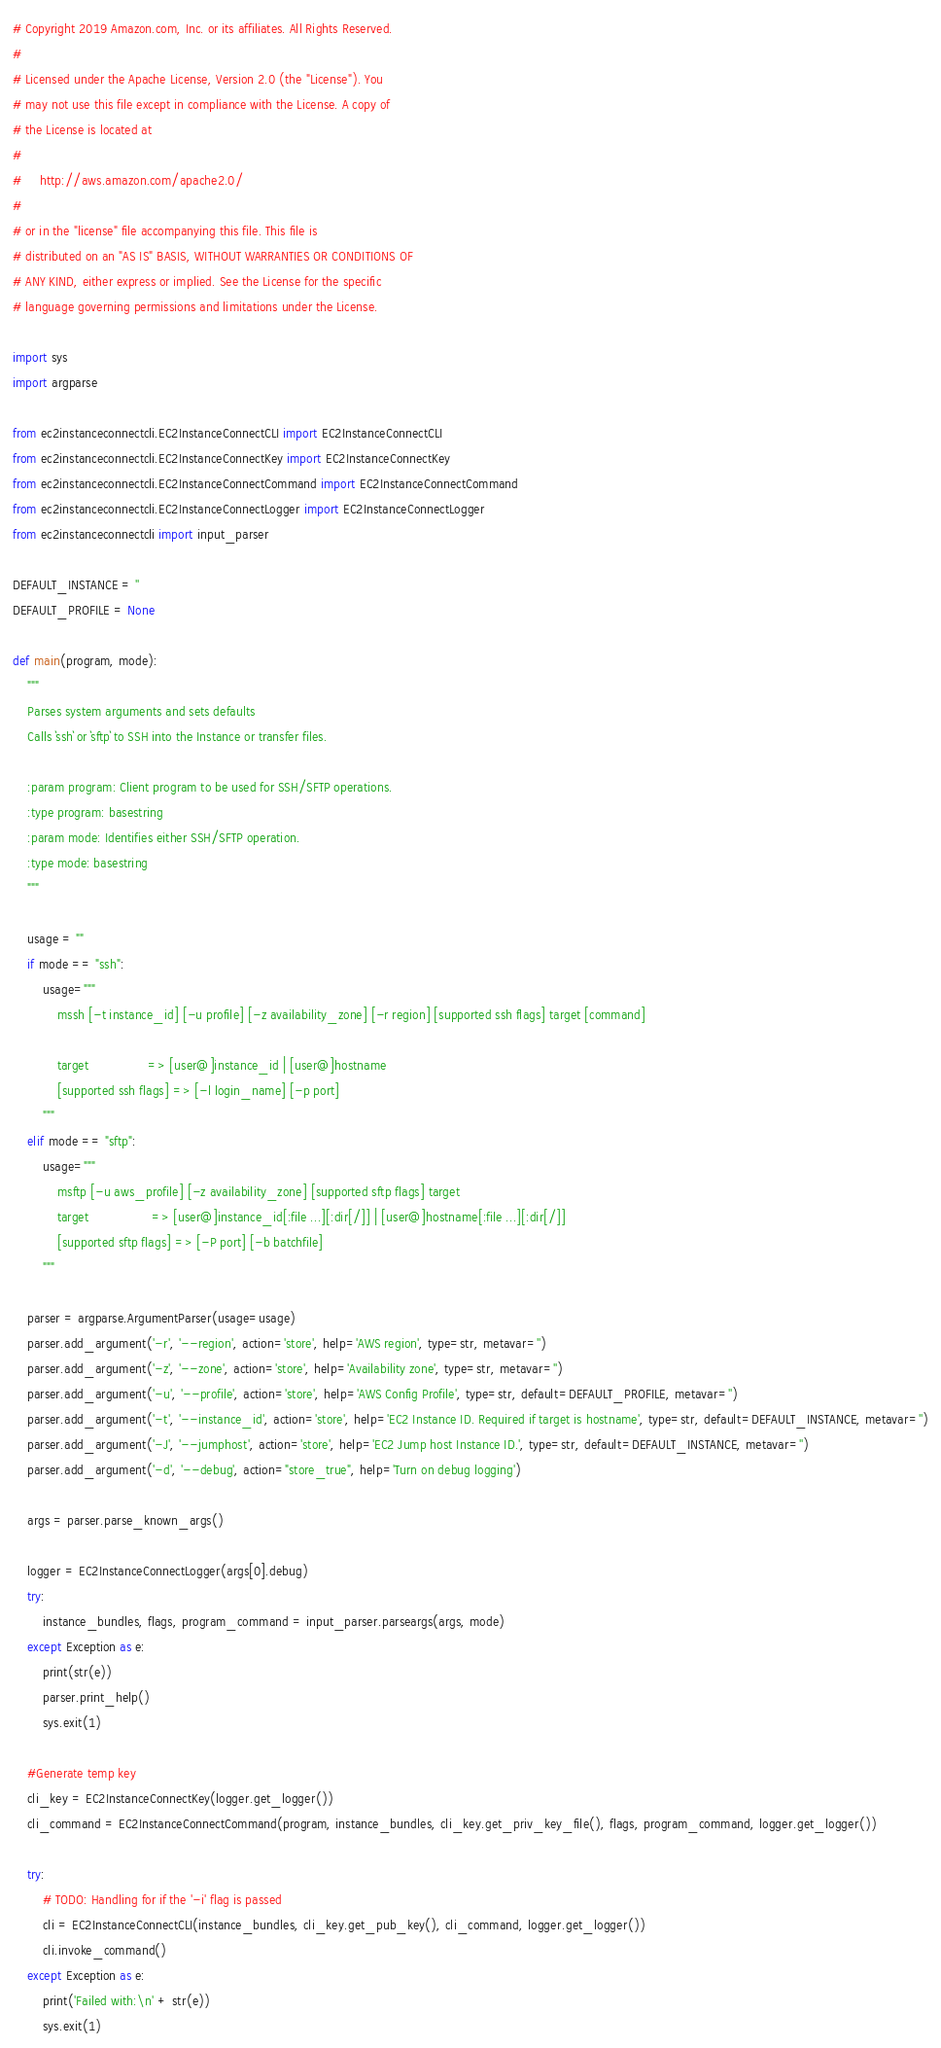Convert code to text. <code><loc_0><loc_0><loc_500><loc_500><_Python_># Copyright 2019 Amazon.com, Inc. or its affiliates. All Rights Reserved.
#
# Licensed under the Apache License, Version 2.0 (the "License"). You
# may not use this file except in compliance with the License. A copy of
# the License is located at
#
#     http://aws.amazon.com/apache2.0/
#
# or in the "license" file accompanying this file. This file is
# distributed on an "AS IS" BASIS, WITHOUT WARRANTIES OR CONDITIONS OF
# ANY KIND, either express or implied. See the License for the specific
# language governing permissions and limitations under the License.

import sys
import argparse

from ec2instanceconnectcli.EC2InstanceConnectCLI import EC2InstanceConnectCLI
from ec2instanceconnectcli.EC2InstanceConnectKey import EC2InstanceConnectKey
from ec2instanceconnectcli.EC2InstanceConnectCommand import EC2InstanceConnectCommand
from ec2instanceconnectcli.EC2InstanceConnectLogger import EC2InstanceConnectLogger
from ec2instanceconnectcli import input_parser

DEFAULT_INSTANCE = ''
DEFAULT_PROFILE = None

def main(program, mode):
    """
    Parses system arguments and sets defaults
    Calls `ssh` or `sftp` to SSH into the Instance or transfer files.

    :param program: Client program to be used for SSH/SFTP operations.
    :type program: basestring
    :param mode: Identifies either SSH/SFTP operation.
    :type mode: basestring
    """

    usage = ""
    if mode == "ssh":
        usage="""
            mssh [-t instance_id] [-u profile] [-z availability_zone] [-r region] [supported ssh flags] target [command]

            target                => [user@]instance_id | [user@]hostname
            [supported ssh flags] => [-l login_name] [-p port]
        """
    elif mode == "sftp":
        usage="""
            msftp [-u aws_profile] [-z availability_zone] [supported sftp flags] target
            target                 => [user@]instance_id[:file ...][:dir[/]] | [user@]hostname[:file ...][:dir[/]]
            [supported sftp flags] => [-P port] [-b batchfile]
        """

    parser = argparse.ArgumentParser(usage=usage)
    parser.add_argument('-r', '--region', action='store', help='AWS region', type=str, metavar='')
    parser.add_argument('-z', '--zone', action='store', help='Availability zone', type=str, metavar='')
    parser.add_argument('-u', '--profile', action='store', help='AWS Config Profile', type=str, default=DEFAULT_PROFILE, metavar='')
    parser.add_argument('-t', '--instance_id', action='store', help='EC2 Instance ID. Required if target is hostname', type=str, default=DEFAULT_INSTANCE, metavar='')
    parser.add_argument('-J', '--jumphost', action='store', help='EC2 Jump host Instance ID.', type=str, default=DEFAULT_INSTANCE, metavar='')
    parser.add_argument('-d', '--debug', action="store_true", help='Turn on debug logging')

    args = parser.parse_known_args()

    logger = EC2InstanceConnectLogger(args[0].debug)
    try:
        instance_bundles, flags, program_command = input_parser.parseargs(args, mode)
    except Exception as e:
        print(str(e))
        parser.print_help()
        sys.exit(1)

    #Generate temp key
    cli_key = EC2InstanceConnectKey(logger.get_logger())
    cli_command = EC2InstanceConnectCommand(program, instance_bundles, cli_key.get_priv_key_file(), flags, program_command, logger.get_logger())

    try:
        # TODO: Handling for if the '-i' flag is passed
        cli = EC2InstanceConnectCLI(instance_bundles, cli_key.get_pub_key(), cli_command, logger.get_logger())
        cli.invoke_command()
    except Exception as e:
        print('Failed with:\n' + str(e))
        sys.exit(1)
</code> 